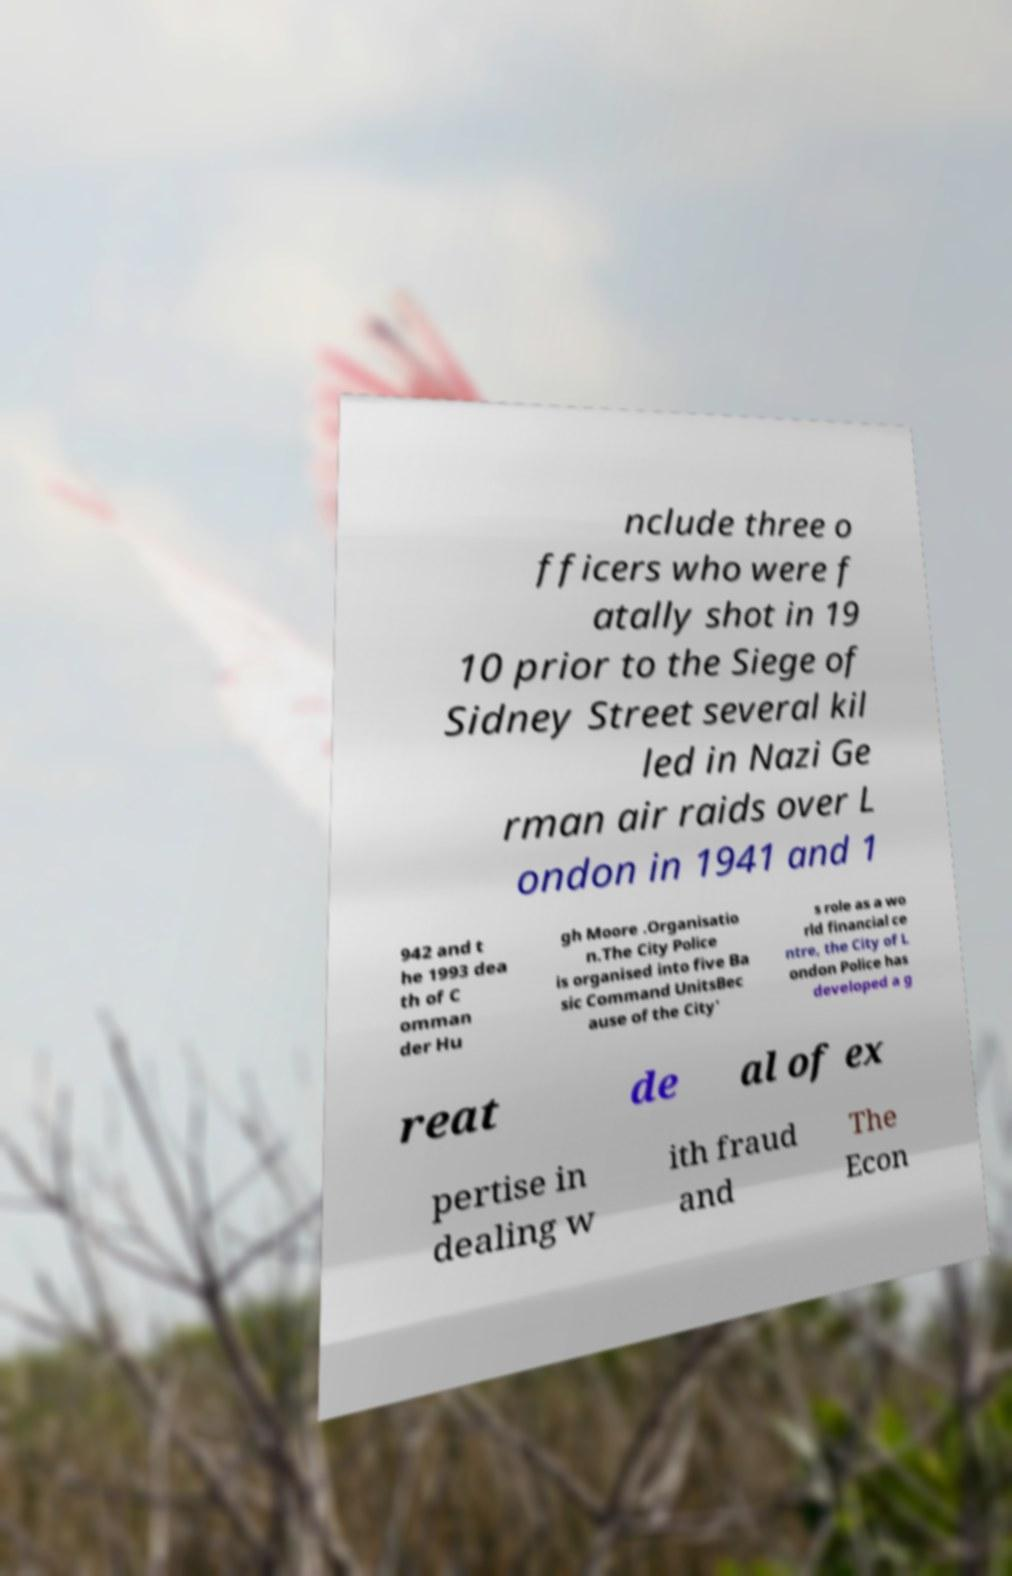Please read and relay the text visible in this image. What does it say? nclude three o fficers who were f atally shot in 19 10 prior to the Siege of Sidney Street several kil led in Nazi Ge rman air raids over L ondon in 1941 and 1 942 and t he 1993 dea th of C omman der Hu gh Moore .Organisatio n.The City Police is organised into five Ba sic Command UnitsBec ause of the City' s role as a wo rld financial ce ntre, the City of L ondon Police has developed a g reat de al of ex pertise in dealing w ith fraud and The Econ 